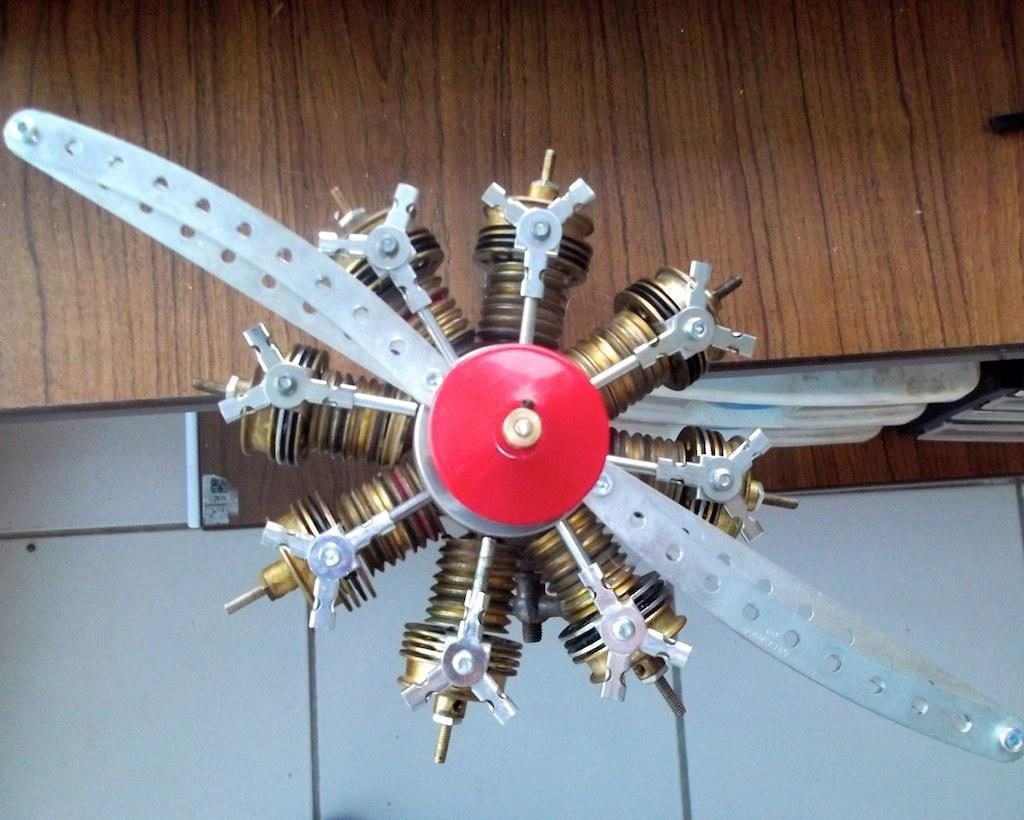What is the main subject in the image? There is an object in the image. What can be seen in the background of the image? There is a wall visible in the background of the image. Are there any other objects present in the background? Yes, there are some objects present in the background of the image. How many geese are flying in the image? There are no geese present in the image. What type of flight is depicted in the image? There is no flight depicted in the image; it only features an object and a wall in the background. 